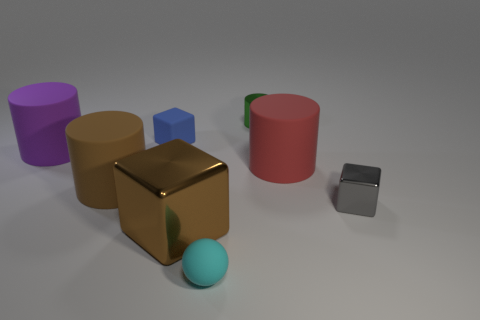Subtract 0 cyan cylinders. How many objects are left? 8 Subtract all balls. How many objects are left? 7 Subtract 1 cubes. How many cubes are left? 2 Subtract all gray balls. Subtract all purple cylinders. How many balls are left? 1 Subtract all purple blocks. How many blue spheres are left? 0 Subtract all large purple cylinders. Subtract all green shiny cylinders. How many objects are left? 6 Add 2 gray shiny cubes. How many gray shiny cubes are left? 3 Add 2 big blue metallic objects. How many big blue metallic objects exist? 2 Add 1 large gray things. How many objects exist? 9 Subtract all purple cylinders. How many cylinders are left? 3 